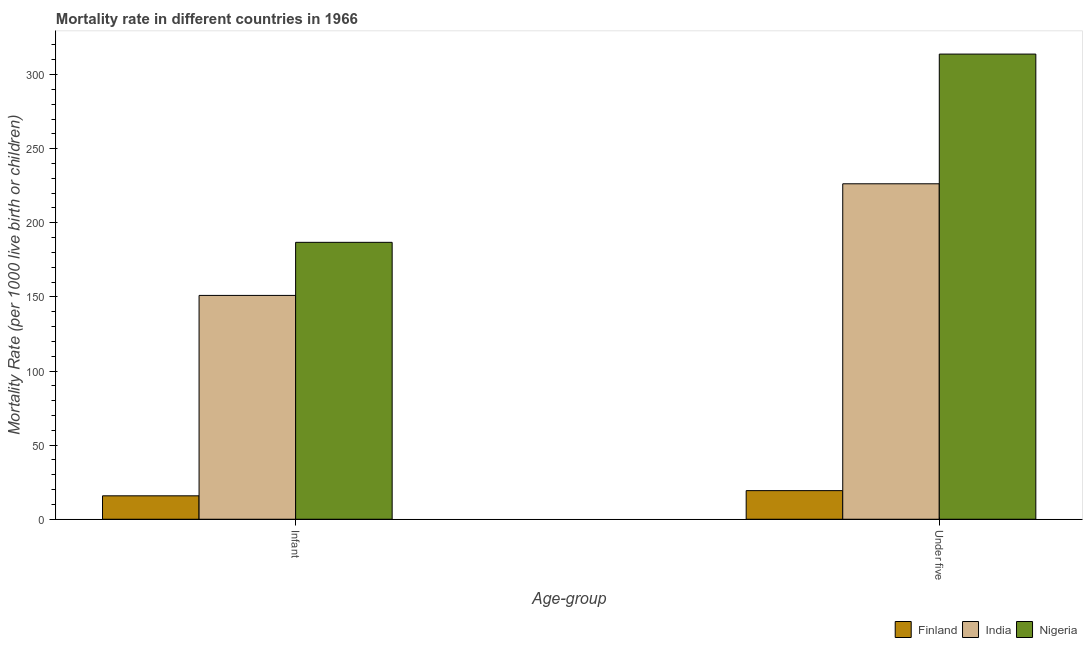How many groups of bars are there?
Ensure brevity in your answer.  2. Are the number of bars per tick equal to the number of legend labels?
Offer a very short reply. Yes. Are the number of bars on each tick of the X-axis equal?
Provide a succinct answer. Yes. How many bars are there on the 1st tick from the left?
Make the answer very short. 3. What is the label of the 1st group of bars from the left?
Offer a terse response. Infant. What is the under-5 mortality rate in Finland?
Give a very brief answer. 19.3. Across all countries, what is the maximum infant mortality rate?
Your answer should be compact. 186.8. Across all countries, what is the minimum infant mortality rate?
Provide a short and direct response. 15.8. In which country was the under-5 mortality rate maximum?
Provide a succinct answer. Nigeria. What is the total infant mortality rate in the graph?
Your response must be concise. 353.6. What is the difference between the infant mortality rate in Finland and that in Nigeria?
Ensure brevity in your answer.  -171. What is the difference between the under-5 mortality rate in Finland and the infant mortality rate in Nigeria?
Your answer should be very brief. -167.5. What is the average under-5 mortality rate per country?
Your response must be concise. 186.47. What is the difference between the under-5 mortality rate and infant mortality rate in India?
Provide a short and direct response. 75.3. In how many countries, is the under-5 mortality rate greater than 10 ?
Your response must be concise. 3. What is the ratio of the infant mortality rate in India to that in Finland?
Provide a succinct answer. 9.56. Is the infant mortality rate in Nigeria less than that in India?
Your answer should be very brief. No. In how many countries, is the under-5 mortality rate greater than the average under-5 mortality rate taken over all countries?
Your response must be concise. 2. What does the 3rd bar from the left in Under five represents?
Ensure brevity in your answer.  Nigeria. How many bars are there?
Offer a very short reply. 6. Are the values on the major ticks of Y-axis written in scientific E-notation?
Keep it short and to the point. No. Does the graph contain any zero values?
Offer a terse response. No. Does the graph contain grids?
Provide a succinct answer. No. How many legend labels are there?
Keep it short and to the point. 3. How are the legend labels stacked?
Offer a very short reply. Horizontal. What is the title of the graph?
Your answer should be very brief. Mortality rate in different countries in 1966. What is the label or title of the X-axis?
Make the answer very short. Age-group. What is the label or title of the Y-axis?
Ensure brevity in your answer.  Mortality Rate (per 1000 live birth or children). What is the Mortality Rate (per 1000 live birth or children) of India in Infant?
Offer a terse response. 151. What is the Mortality Rate (per 1000 live birth or children) in Nigeria in Infant?
Provide a short and direct response. 186.8. What is the Mortality Rate (per 1000 live birth or children) in Finland in Under five?
Your response must be concise. 19.3. What is the Mortality Rate (per 1000 live birth or children) of India in Under five?
Make the answer very short. 226.3. What is the Mortality Rate (per 1000 live birth or children) in Nigeria in Under five?
Offer a terse response. 313.8. Across all Age-group, what is the maximum Mortality Rate (per 1000 live birth or children) in Finland?
Keep it short and to the point. 19.3. Across all Age-group, what is the maximum Mortality Rate (per 1000 live birth or children) in India?
Your answer should be compact. 226.3. Across all Age-group, what is the maximum Mortality Rate (per 1000 live birth or children) of Nigeria?
Give a very brief answer. 313.8. Across all Age-group, what is the minimum Mortality Rate (per 1000 live birth or children) of Finland?
Keep it short and to the point. 15.8. Across all Age-group, what is the minimum Mortality Rate (per 1000 live birth or children) of India?
Offer a terse response. 151. Across all Age-group, what is the minimum Mortality Rate (per 1000 live birth or children) of Nigeria?
Offer a very short reply. 186.8. What is the total Mortality Rate (per 1000 live birth or children) in Finland in the graph?
Your response must be concise. 35.1. What is the total Mortality Rate (per 1000 live birth or children) of India in the graph?
Your answer should be compact. 377.3. What is the total Mortality Rate (per 1000 live birth or children) in Nigeria in the graph?
Keep it short and to the point. 500.6. What is the difference between the Mortality Rate (per 1000 live birth or children) in Finland in Infant and that in Under five?
Make the answer very short. -3.5. What is the difference between the Mortality Rate (per 1000 live birth or children) in India in Infant and that in Under five?
Provide a succinct answer. -75.3. What is the difference between the Mortality Rate (per 1000 live birth or children) of Nigeria in Infant and that in Under five?
Keep it short and to the point. -127. What is the difference between the Mortality Rate (per 1000 live birth or children) of Finland in Infant and the Mortality Rate (per 1000 live birth or children) of India in Under five?
Offer a terse response. -210.5. What is the difference between the Mortality Rate (per 1000 live birth or children) of Finland in Infant and the Mortality Rate (per 1000 live birth or children) of Nigeria in Under five?
Provide a succinct answer. -298. What is the difference between the Mortality Rate (per 1000 live birth or children) of India in Infant and the Mortality Rate (per 1000 live birth or children) of Nigeria in Under five?
Your answer should be compact. -162.8. What is the average Mortality Rate (per 1000 live birth or children) of Finland per Age-group?
Provide a succinct answer. 17.55. What is the average Mortality Rate (per 1000 live birth or children) of India per Age-group?
Ensure brevity in your answer.  188.65. What is the average Mortality Rate (per 1000 live birth or children) in Nigeria per Age-group?
Your answer should be compact. 250.3. What is the difference between the Mortality Rate (per 1000 live birth or children) of Finland and Mortality Rate (per 1000 live birth or children) of India in Infant?
Provide a succinct answer. -135.2. What is the difference between the Mortality Rate (per 1000 live birth or children) of Finland and Mortality Rate (per 1000 live birth or children) of Nigeria in Infant?
Your response must be concise. -171. What is the difference between the Mortality Rate (per 1000 live birth or children) in India and Mortality Rate (per 1000 live birth or children) in Nigeria in Infant?
Offer a terse response. -35.8. What is the difference between the Mortality Rate (per 1000 live birth or children) in Finland and Mortality Rate (per 1000 live birth or children) in India in Under five?
Make the answer very short. -207. What is the difference between the Mortality Rate (per 1000 live birth or children) of Finland and Mortality Rate (per 1000 live birth or children) of Nigeria in Under five?
Give a very brief answer. -294.5. What is the difference between the Mortality Rate (per 1000 live birth or children) of India and Mortality Rate (per 1000 live birth or children) of Nigeria in Under five?
Your response must be concise. -87.5. What is the ratio of the Mortality Rate (per 1000 live birth or children) of Finland in Infant to that in Under five?
Your answer should be compact. 0.82. What is the ratio of the Mortality Rate (per 1000 live birth or children) in India in Infant to that in Under five?
Keep it short and to the point. 0.67. What is the ratio of the Mortality Rate (per 1000 live birth or children) in Nigeria in Infant to that in Under five?
Your response must be concise. 0.6. What is the difference between the highest and the second highest Mortality Rate (per 1000 live birth or children) of Finland?
Offer a very short reply. 3.5. What is the difference between the highest and the second highest Mortality Rate (per 1000 live birth or children) in India?
Your response must be concise. 75.3. What is the difference between the highest and the second highest Mortality Rate (per 1000 live birth or children) of Nigeria?
Keep it short and to the point. 127. What is the difference between the highest and the lowest Mortality Rate (per 1000 live birth or children) in Finland?
Your answer should be very brief. 3.5. What is the difference between the highest and the lowest Mortality Rate (per 1000 live birth or children) of India?
Your answer should be compact. 75.3. What is the difference between the highest and the lowest Mortality Rate (per 1000 live birth or children) of Nigeria?
Your answer should be very brief. 127. 